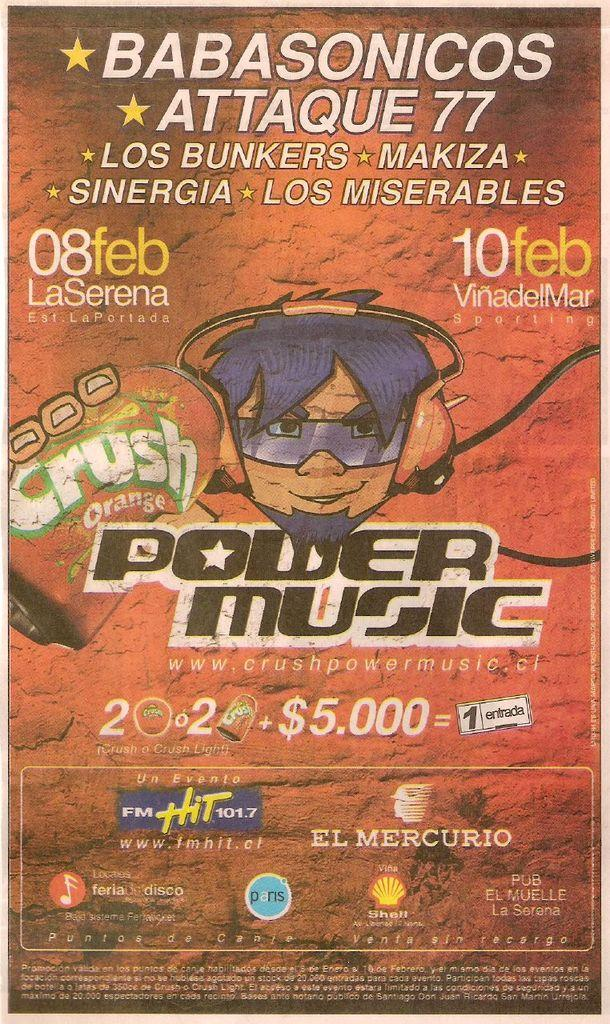<image>
Summarize the visual content of the image. A poster promotes Power Music and includes the drawn image of a face and a can of Orange Crush. 